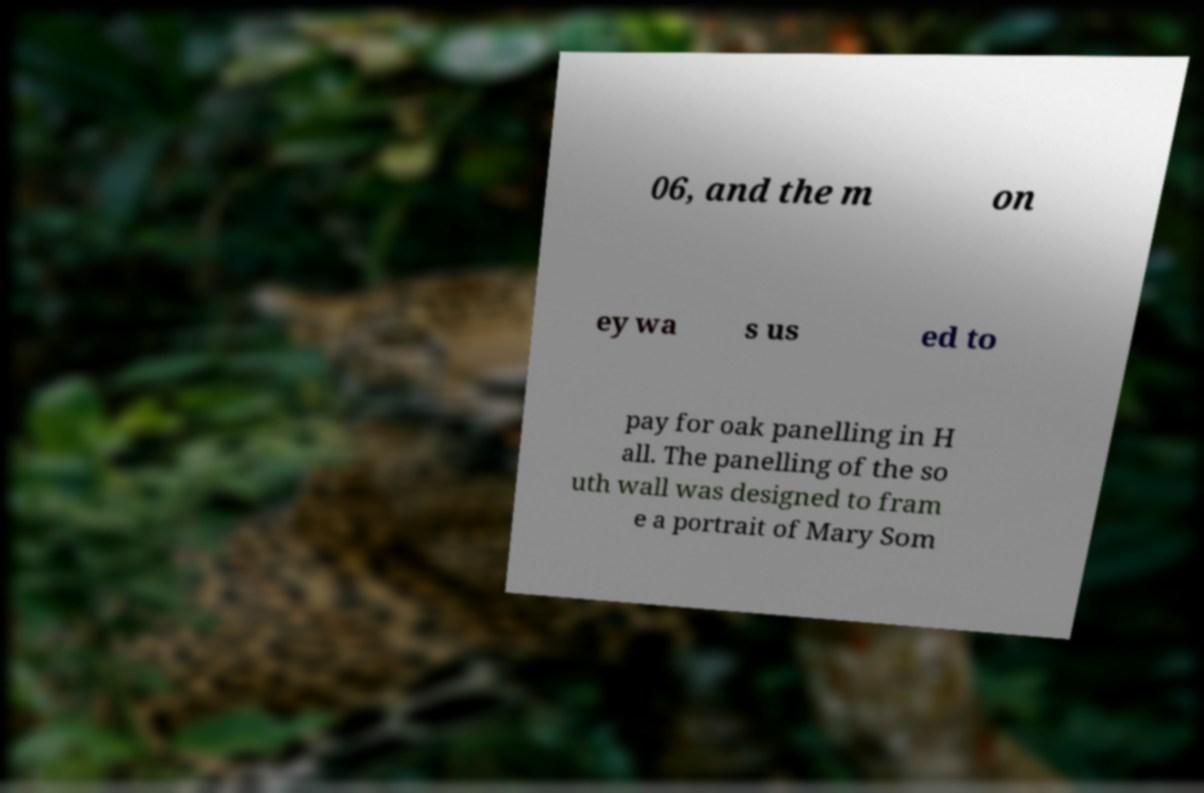Could you extract and type out the text from this image? 06, and the m on ey wa s us ed to pay for oak panelling in H all. The panelling of the so uth wall was designed to fram e a portrait of Mary Som 